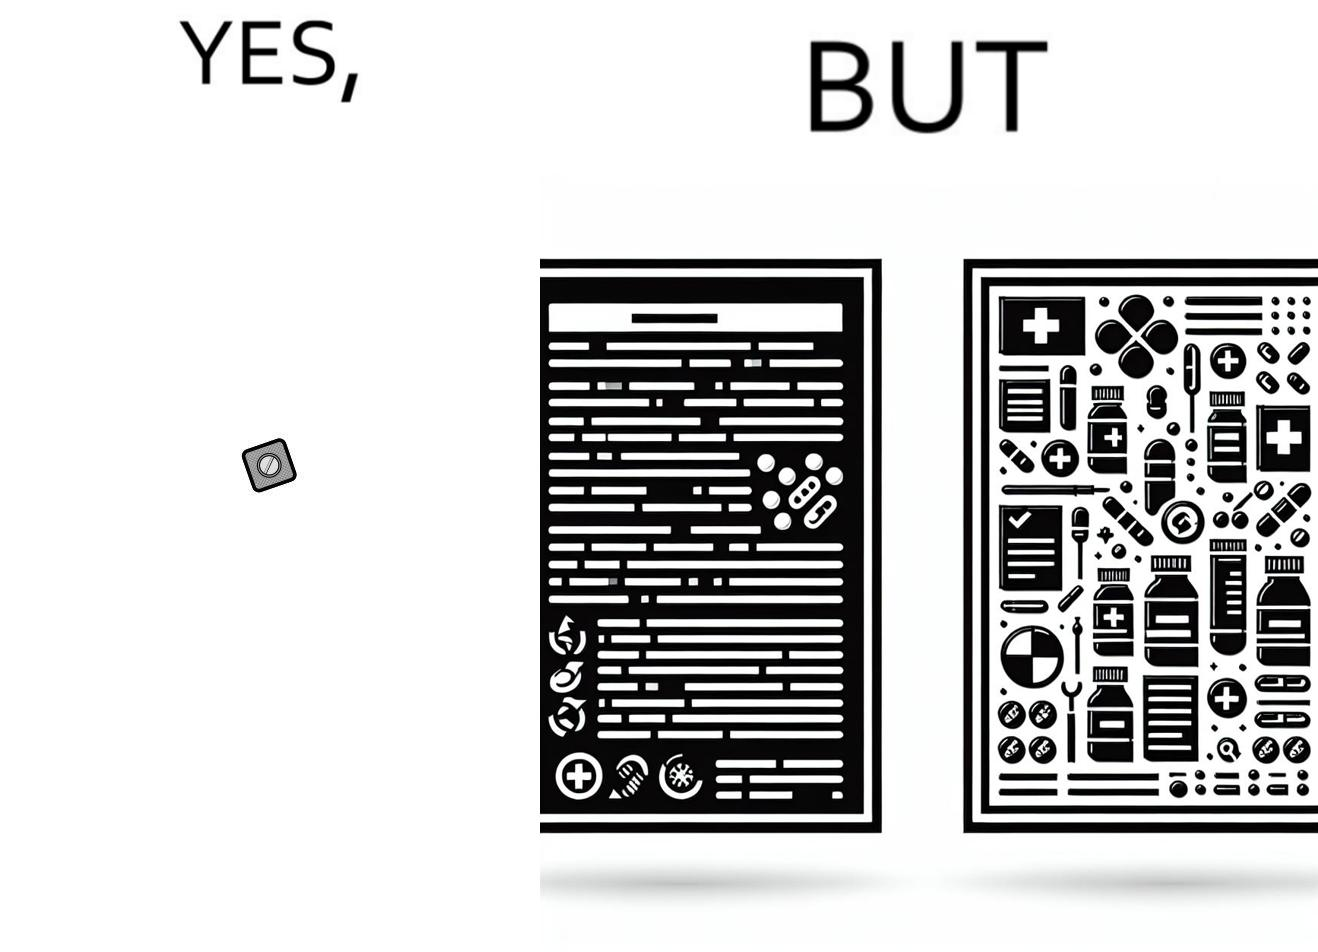Describe what you see in the left and right parts of this image. In the left part of the image: a small tablet of a medicine In the right part of the image: a leaflet describing the instructions for a medicine 